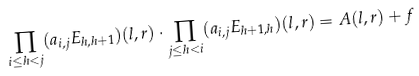Convert formula to latex. <formula><loc_0><loc_0><loc_500><loc_500>\prod _ { i \leq h < j } ( a _ { i , j } E _ { h , h + 1 } ) ( l , r ) \cdot \prod _ { j \leq h < i } ( a _ { i , j } E _ { h + 1 , h } ) ( l , r ) = A ( l , r ) + f</formula> 